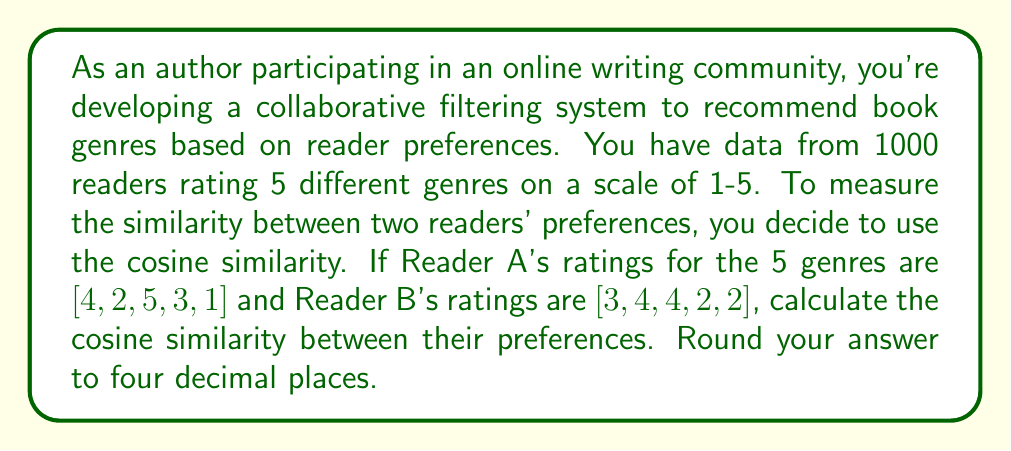Help me with this question. To calculate the cosine similarity between two readers' preferences, we'll follow these steps:

1. Recall the formula for cosine similarity:

   $$\text{Cosine Similarity} = \frac{\mathbf{A} \cdot \mathbf{B}}{\|\mathbf{A}\| \|\mathbf{B}\|}$$

   Where $\mathbf{A}$ and $\mathbf{B}$ are the rating vectors, $\cdot$ represents the dot product, and $\|\mathbf{A}\|$ and $\|\mathbf{B}\|$ are the magnitudes of the vectors.

2. Calculate the dot product $\mathbf{A} \cdot \mathbf{B}$:
   $$(4 \times 3) + (2 \times 4) + (5 \times 4) + (3 \times 2) + (1 \times 2) = 12 + 8 + 20 + 6 + 2 = 48$$

3. Calculate the magnitude of vector $\mathbf{A}$:
   $$\|\mathbf{A}\| = \sqrt{4^2 + 2^2 + 5^2 + 3^2 + 1^2} = \sqrt{16 + 4 + 25 + 9 + 1} = \sqrt{55} \approx 7.4162$$

4. Calculate the magnitude of vector $\mathbf{B}$:
   $$\|\mathbf{B}\| = \sqrt{3^2 + 4^2 + 4^2 + 2^2 + 2^2} = \sqrt{9 + 16 + 16 + 4 + 4} = \sqrt{49} = 7$$

5. Apply the cosine similarity formula:
   $$\text{Cosine Similarity} = \frac{48}{7.4162 \times 7} \approx 0.9246$$

6. Round the result to four decimal places: 0.9246

This high cosine similarity (close to 1) indicates that Readers A and B have relatively similar preferences across the five book genres.
Answer: 0.9246 